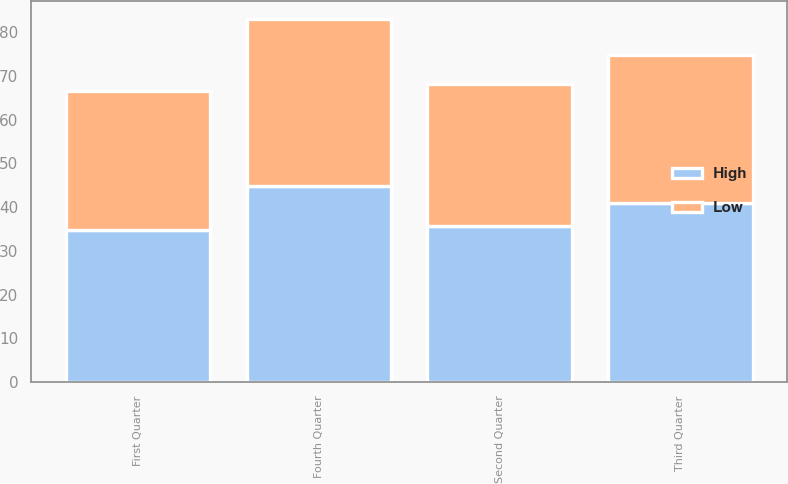<chart> <loc_0><loc_0><loc_500><loc_500><stacked_bar_chart><ecel><fcel>First Quarter<fcel>Second Quarter<fcel>Third Quarter<fcel>Fourth Quarter<nl><fcel>High<fcel>34.67<fcel>35.73<fcel>41.01<fcel>44.71<nl><fcel>Low<fcel>31.79<fcel>32.34<fcel>33.72<fcel>38.31<nl></chart> 